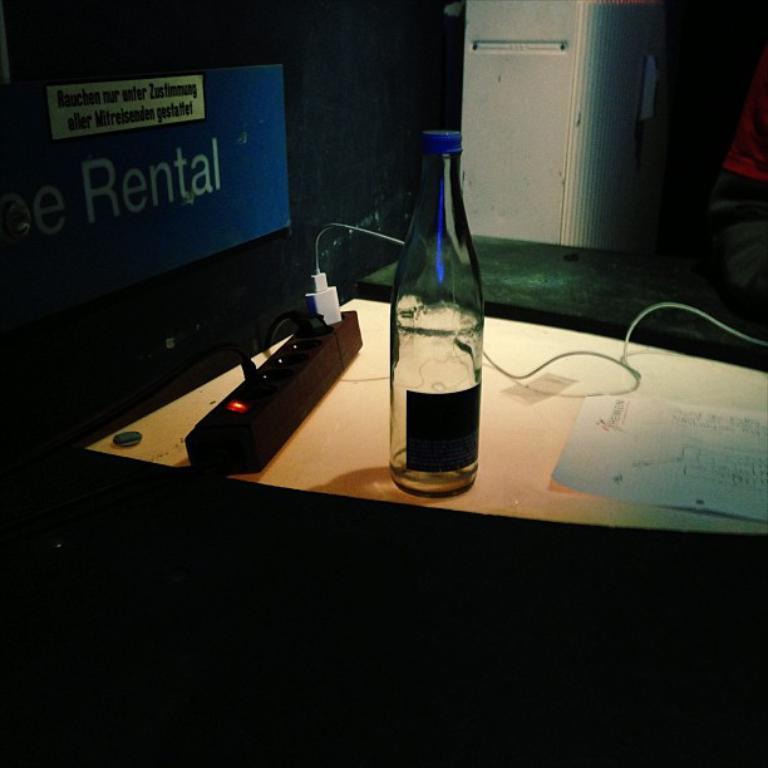What is the word that starts with r in the photo?
Give a very brief answer. Rental. 